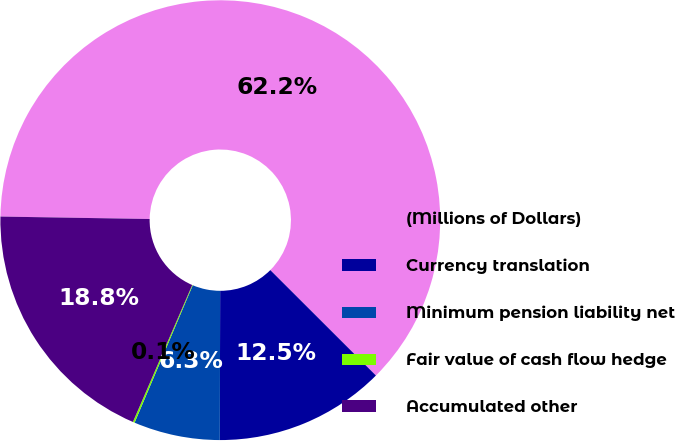Convert chart to OTSL. <chart><loc_0><loc_0><loc_500><loc_500><pie_chart><fcel>(Millions of Dollars)<fcel>Currency translation<fcel>Minimum pension liability net<fcel>Fair value of cash flow hedge<fcel>Accumulated other<nl><fcel>62.23%<fcel>12.55%<fcel>6.34%<fcel>0.13%<fcel>18.76%<nl></chart> 